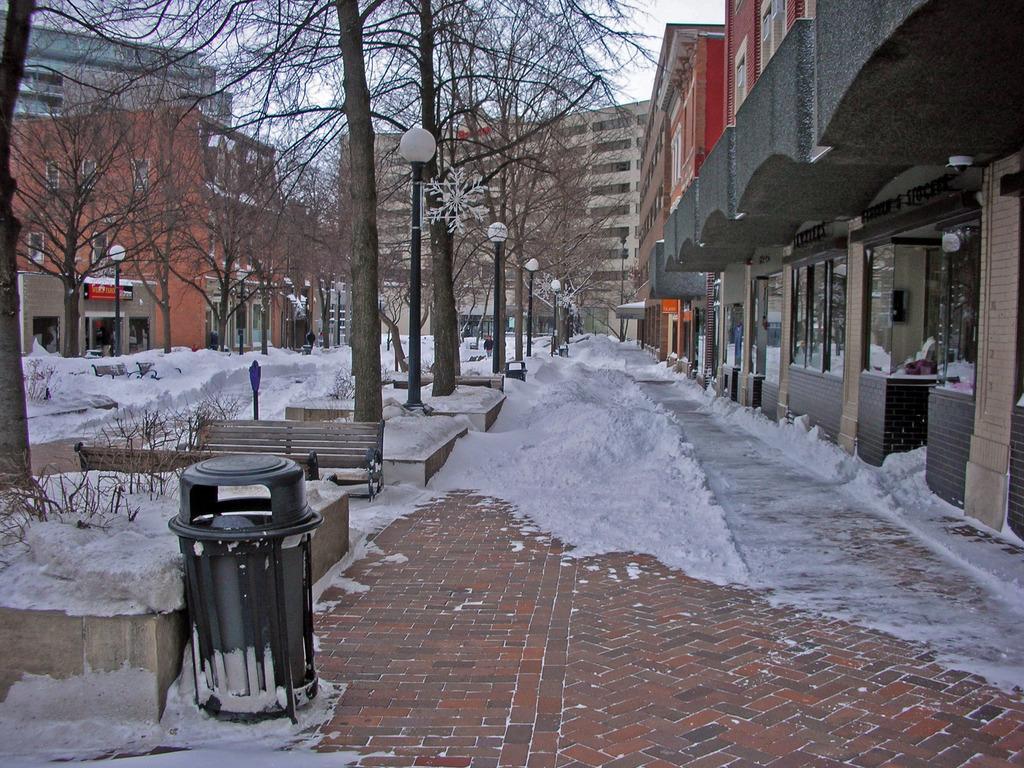Please provide a concise description of this image. On the right side of the image there is a building with walls and glasses. In front of the building on the footpath there is snow. In front of the image there is a bin. Behind the bin there are benches. In the image there are many trees and also there is snow on the ground. Behind the trees there are buildings. 